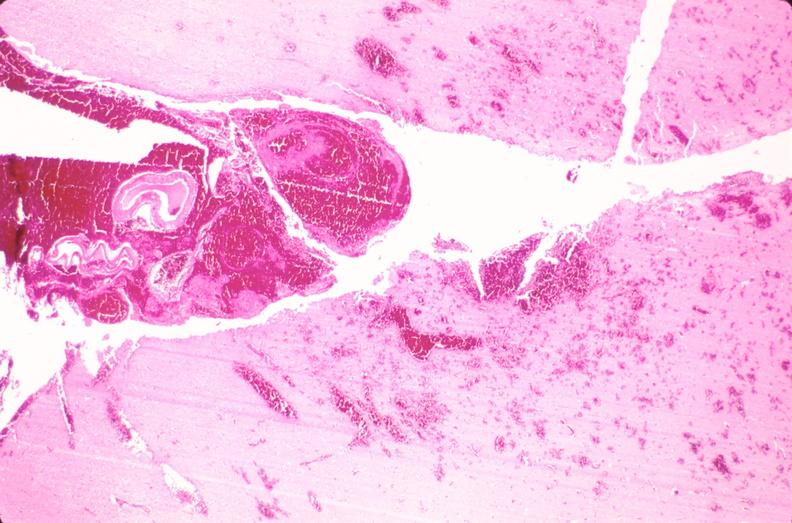what is present?
Answer the question using a single word or phrase. Nervous 